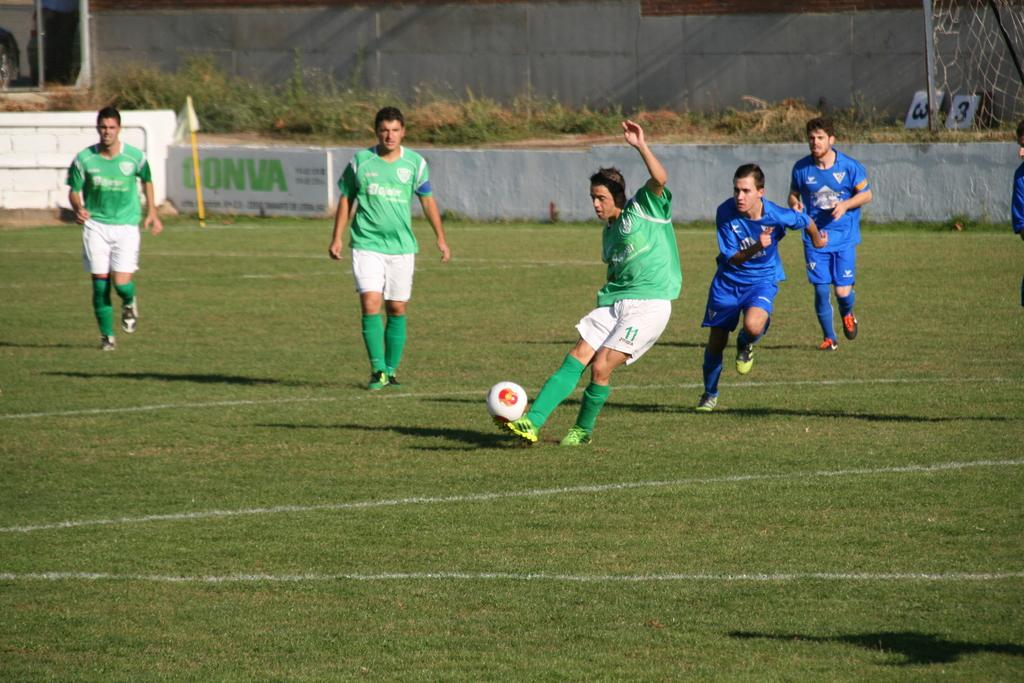<image>
Present a compact description of the photo's key features. player 11 in green and white kicking the ball and being chased by player in blue 